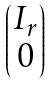<formula> <loc_0><loc_0><loc_500><loc_500>\begin{pmatrix} I _ { r } \\ 0 \end{pmatrix}</formula> 